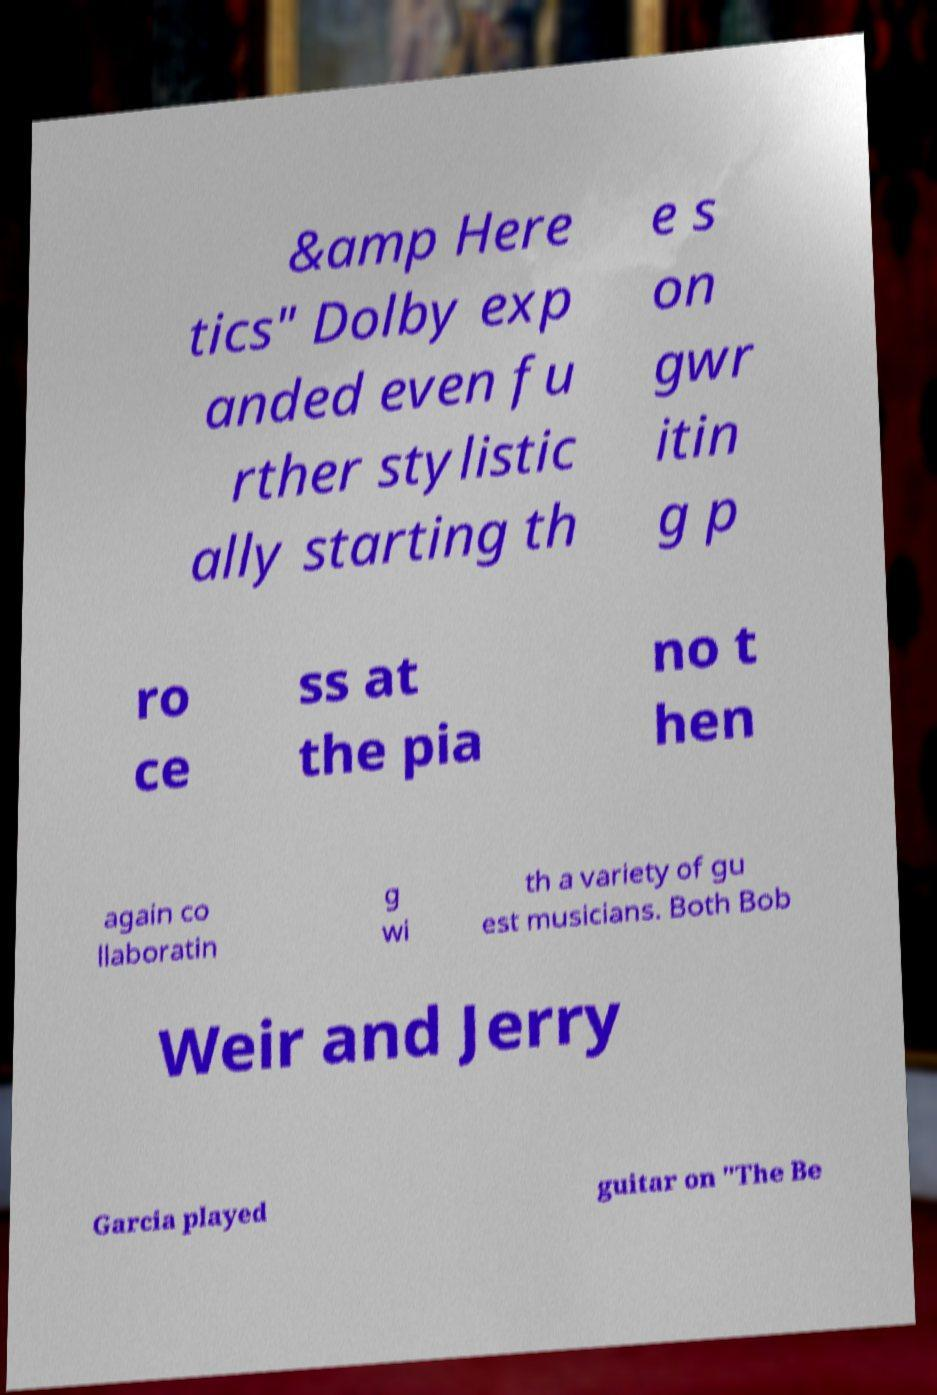Can you accurately transcribe the text from the provided image for me? &amp Here tics" Dolby exp anded even fu rther stylistic ally starting th e s on gwr itin g p ro ce ss at the pia no t hen again co llaboratin g wi th a variety of gu est musicians. Both Bob Weir and Jerry Garcia played guitar on "The Be 